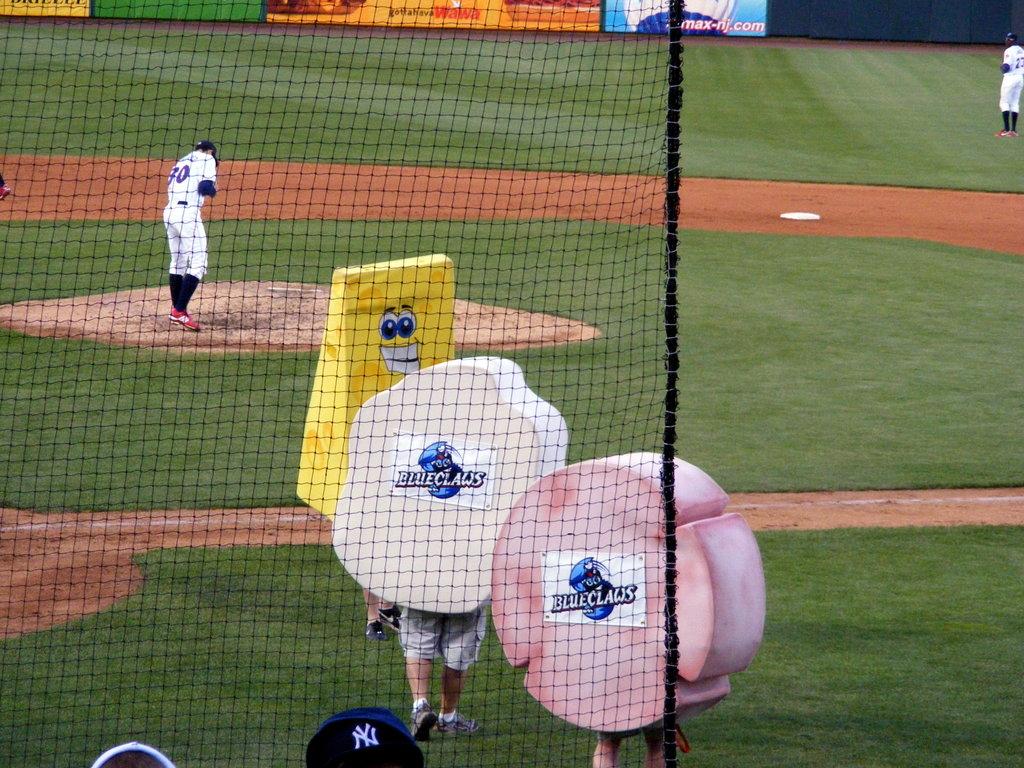What is the player number?
Your answer should be compact. 30. This is sports ground?
Your answer should be very brief. Answering does not require reading text in the image. 